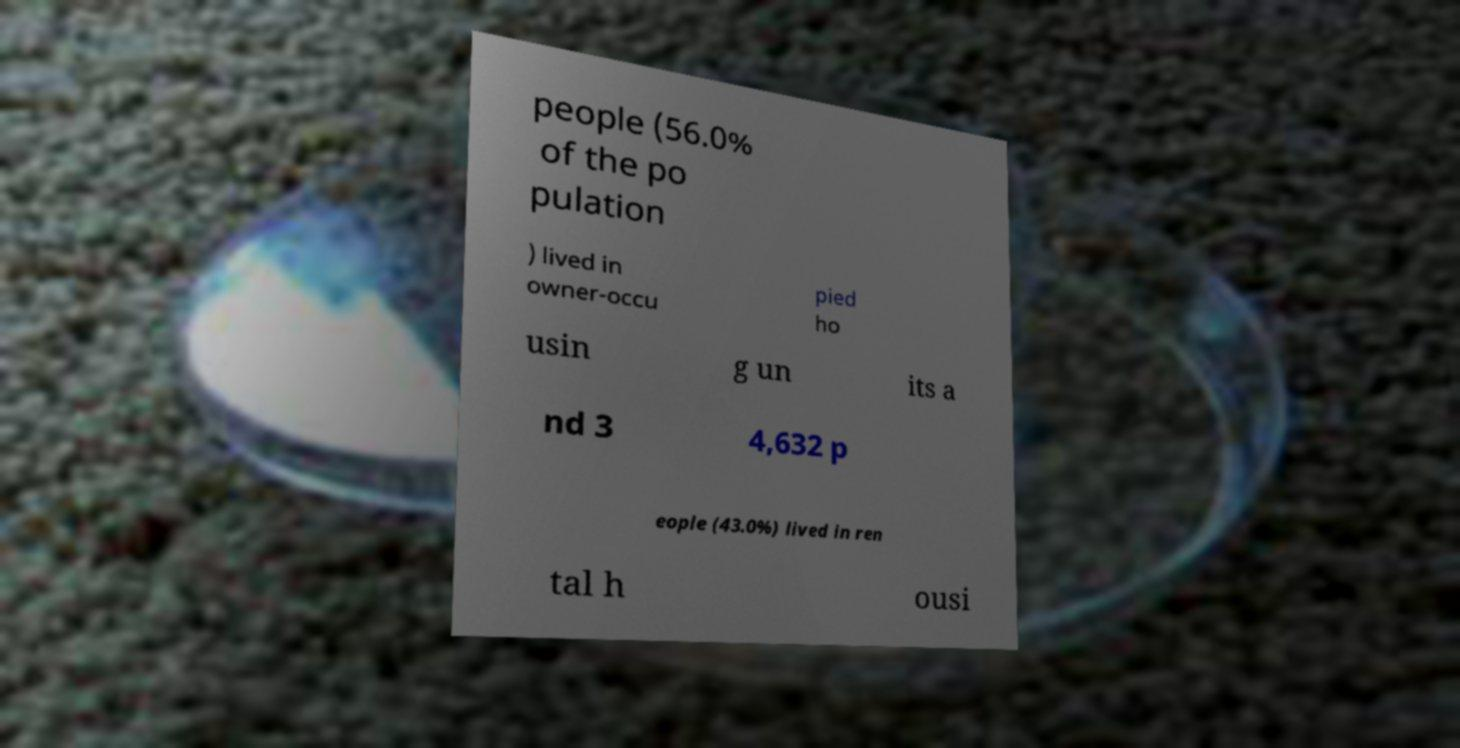Can you read and provide the text displayed in the image?This photo seems to have some interesting text. Can you extract and type it out for me? people (56.0% of the po pulation ) lived in owner-occu pied ho usin g un its a nd 3 4,632 p eople (43.0%) lived in ren tal h ousi 